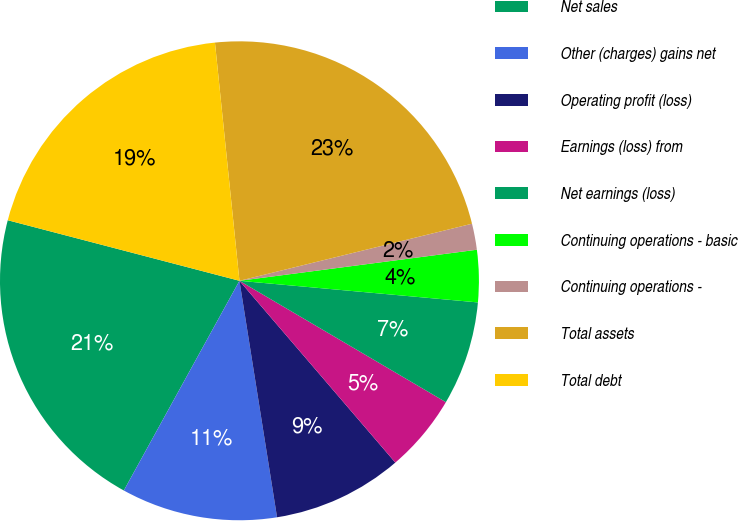Convert chart. <chart><loc_0><loc_0><loc_500><loc_500><pie_chart><fcel>Net sales<fcel>Other (charges) gains net<fcel>Operating profit (loss)<fcel>Earnings (loss) from<fcel>Net earnings (loss)<fcel>Continuing operations - basic<fcel>Continuing operations -<fcel>Total assets<fcel>Total debt<nl><fcel>21.05%<fcel>10.53%<fcel>8.77%<fcel>5.26%<fcel>7.02%<fcel>3.51%<fcel>1.76%<fcel>22.8%<fcel>19.3%<nl></chart> 